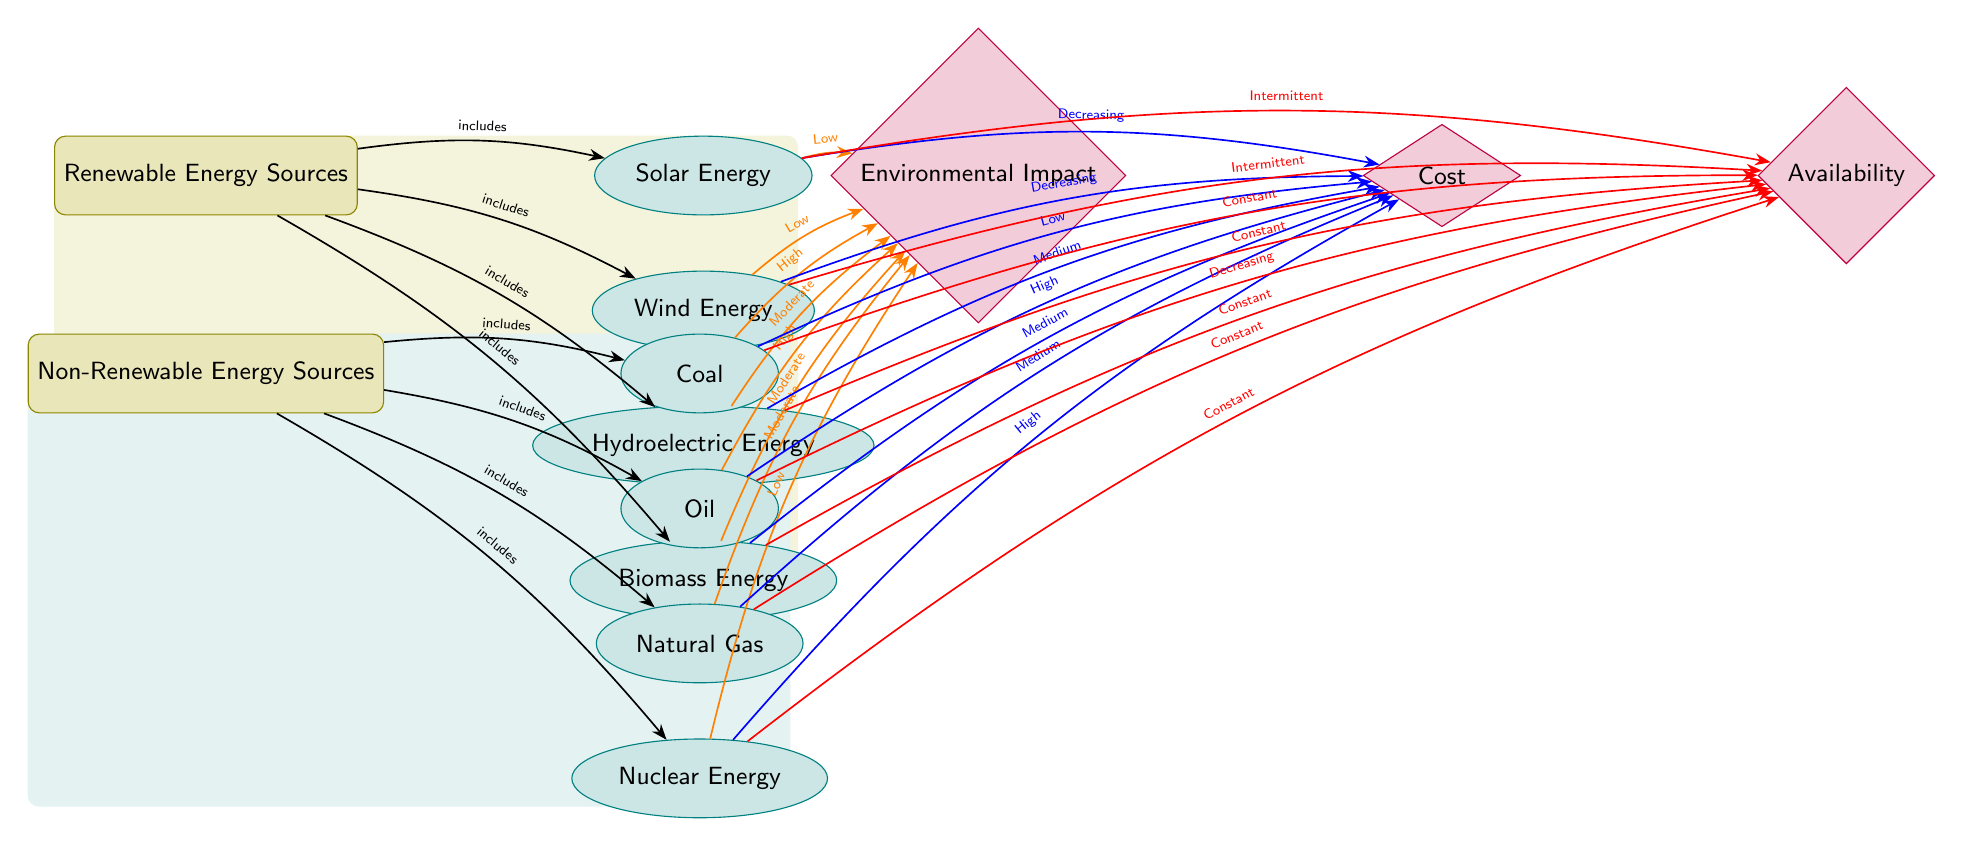What are the four types of renewable energy sources listed in the diagram? The diagram indicates four types of renewable energy sources, which are Solar Energy, Wind Energy, Hydroelectric Energy, and Biomass Energy. These sources are connected to the Renewable Energy Sources node.
Answer: Solar Energy, Wind Energy, Hydroelectric Energy, Biomass Energy How many non-renewable energy sources are depicted in the diagram? The diagram shows four non-renewable energy sources, which are Coal, Oil, Natural Gas, and Nuclear Energy. This information can be gathered by counting the nodes connected to the Non-Renewable Energy Sources node.
Answer: 4 What is the environmental impact of Biomass Energy according to the diagram? The diagram shows that Biomass Energy has a Moderate environmental impact, connecting it to the Environmental Impact factor with the label 'Moderate'.
Answer: Moderate Which type of energy has a Decreasing cost, based on the diagram? The diagram indicates two energy types with a Decreasing cost, which are Solar Energy and Wind Energy. By evaluating the connections to the Cost factor and their labels, we can identify them.
Answer: Solar Energy, Wind Energy Among the non-renewable energy sources, which one has the highest environmental impact? In examining the non-renewable energy sources in the diagram, Coal and Oil are labeled with High environmental impact, but Coal is the first listed. Thus, it is the source noted to have the highest environmental impact here.
Answer: Coal Which renewable energy source is categorized as having Constant availability? The diagram specifies that Hydroelectric Energy and Biomass Energy both have Constant availability. This can be determined by looking at the connections from these sources to the Availability factor and their labels.
Answer: Hydroelectric Energy, Biomass Energy What does the diagram indicate about the availability of Solar Energy? The diagram indicates that Solar Energy has Intermittent availability, which is shown by the connection to the Availability factor from the Solar Energy node with the label 'Intermittent'.
Answer: Intermittent Which non-renewable source is mentioned as having a Low cost? The diagram shows that Coal is indicated as having a Low cost. This information is found by reviewing the relationship between the Non-Renewable Energy Sources and the Cost factor, focusing on the label associated with Coal.
Answer: Low 